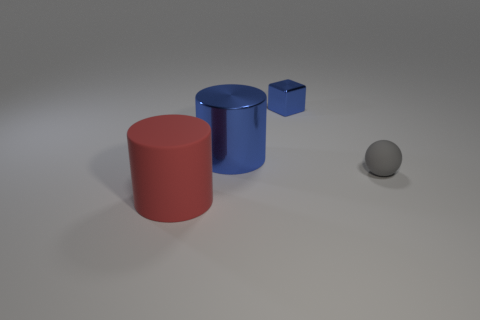Add 1 big purple metallic blocks. How many objects exist? 5 Subtract all red cylinders. How many cylinders are left? 1 Subtract all green blocks. How many blue cylinders are left? 1 Subtract 1 spheres. How many spheres are left? 0 Subtract all brown balls. Subtract all gray cylinders. How many balls are left? 1 Subtract all blue metallic cylinders. Subtract all large blue rubber things. How many objects are left? 3 Add 4 red cylinders. How many red cylinders are left? 5 Add 3 small balls. How many small balls exist? 4 Subtract 0 green cylinders. How many objects are left? 4 